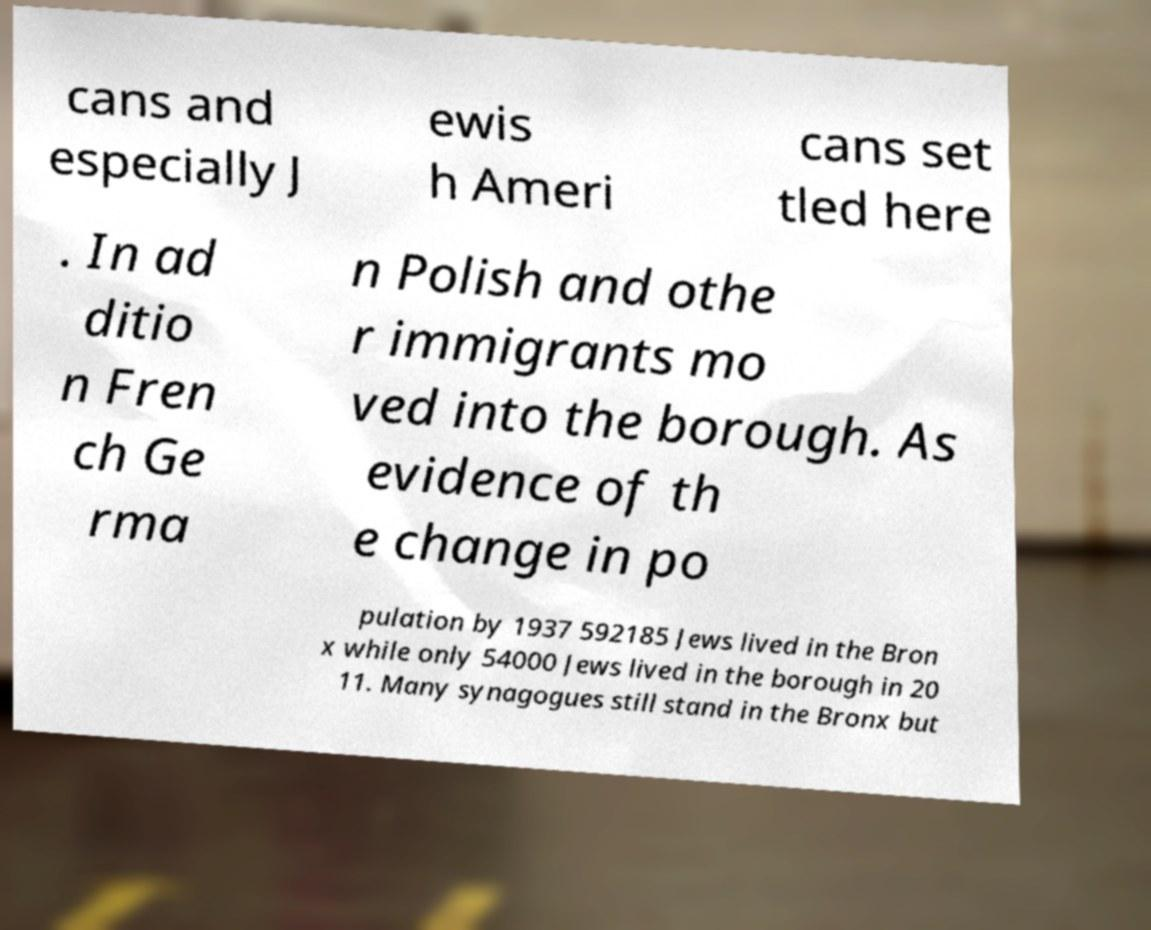For documentation purposes, I need the text within this image transcribed. Could you provide that? cans and especially J ewis h Ameri cans set tled here . In ad ditio n Fren ch Ge rma n Polish and othe r immigrants mo ved into the borough. As evidence of th e change in po pulation by 1937 592185 Jews lived in the Bron x while only 54000 Jews lived in the borough in 20 11. Many synagogues still stand in the Bronx but 